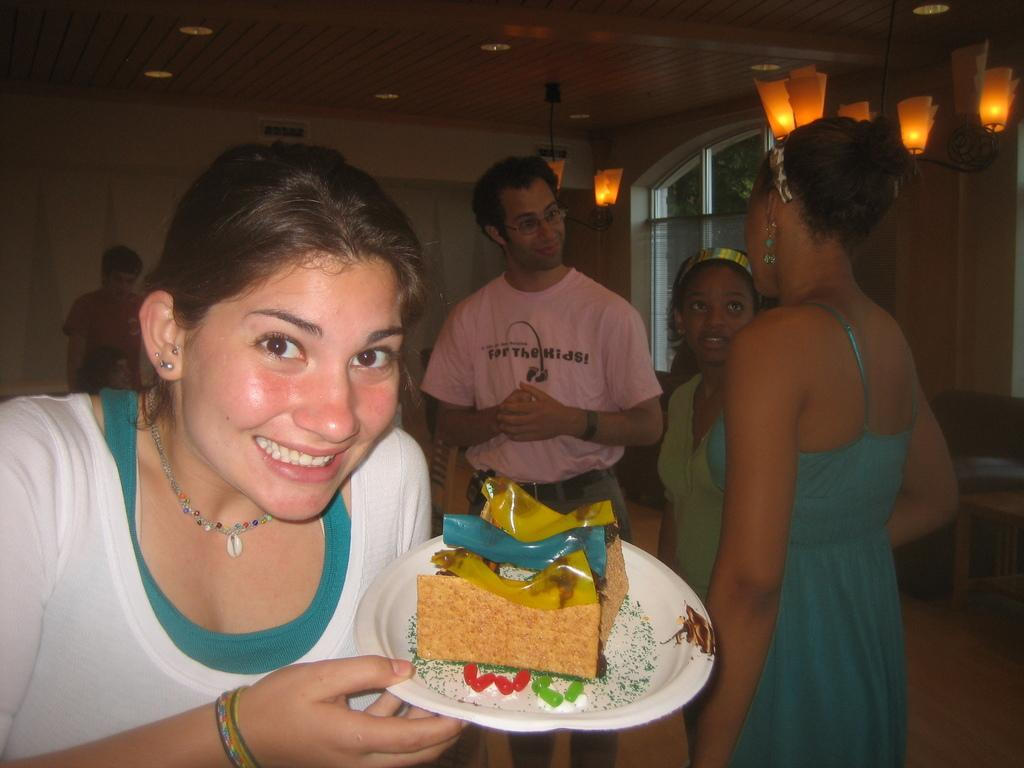What is the woman holding in the image? The woman is holding a plate with food. Can you describe the setting in the background of the image? There are people in the background of the image. What can be seen on the ceiling in the image? Lights are attached to the ceiling. Is there any natural light source visible in the image? Yes, there is a window in the image. How does the woman show respect to the plate in the image? The image does not depict any actions or expressions that indicate respect towards the plate. 